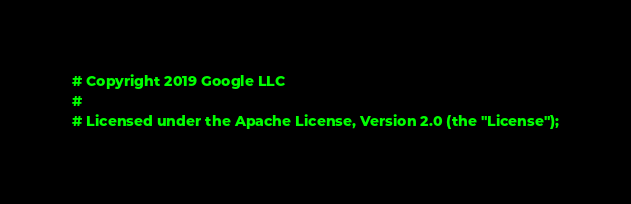Convert code to text. <code><loc_0><loc_0><loc_500><loc_500><_YAML_># Copyright 2019 Google LLC
#
# Licensed under the Apache License, Version 2.0 (the "License");</code> 